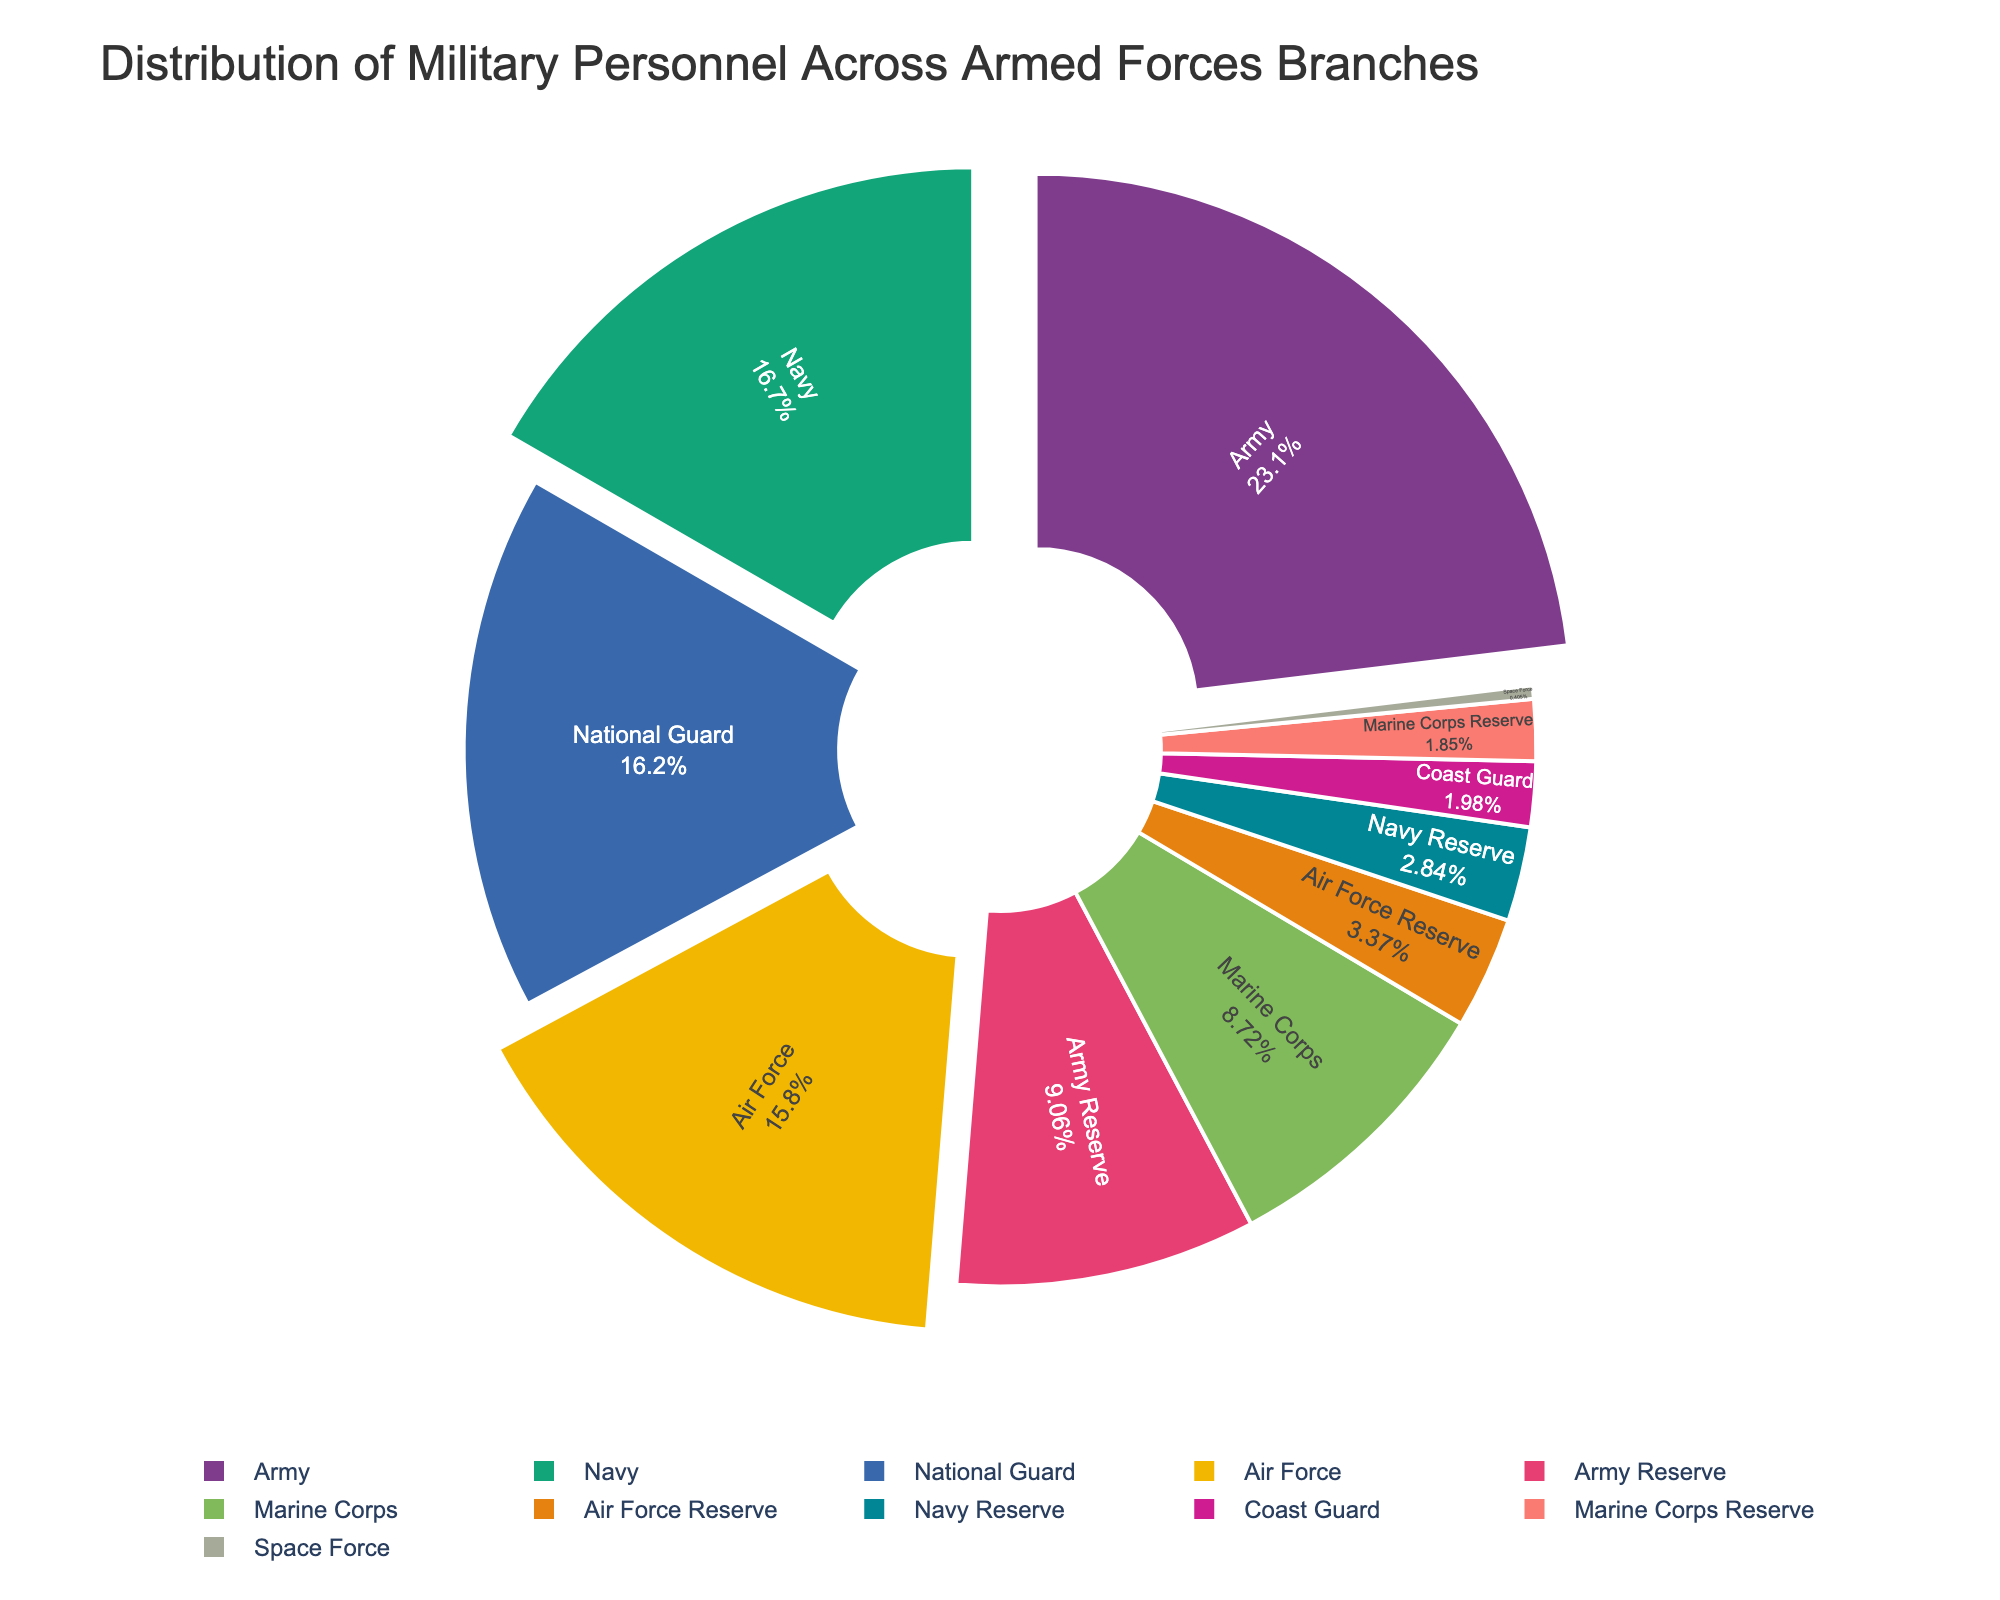Which branch has the highest percentage of military personnel? The percentage for each branch is shown on the pie chart. The Army segment is the largest, indicating the highest percentage of military personnel.
Answer: Army How does the number of personnel in the Marine Corps compare to the Air Force? The pie chart shows segments labeled with percentages and names. The Marine Corps' segment is smaller than the Air Force's, indicating fewer personnel.
Answer: Air Force has more What is the combined percentage of personnel in the Navy and the Marine Corps? Identify and sum the percentages for both segments: Navy's percentage plus the Marine Corps' percentage.
Answer: Navy + Marine Corps' percentage Which branch has the smallest share of military personnel? Look at the segment with the smallest label; the Space Force takes up the smallest portion of the pie chart.
Answer: Space Force Is the personnel in the National Guard greater than the personnel in the Air Force? Compare the sizes of their respective segments. The National Guard segment is larger, indicating more personnel.
Answer: Yes How many branches have more than 100,000 personnel? Count the segments with percentages that indicate a high number of personnel. These would be Army, Navy, Air Force, National Guard, Army Reserve.
Answer: Five What is the total percentage of reserve personnel across all branches? Add the percentages for Army Reserve, Navy Reserve, Air Force Reserve, and Marine Corps Reserve segments.
Answer: Sum of reserve percentages Which two branches have a combined percentage closest to that of the Army? Compare the Army segment's size to various combinations of other segments, finding that the Navy and National Guard segments together closely match.
Answer: Navy + National Guard How does the Coast Guard's percentage compare to that of the Space Force? The Coast Guard segment is larger than the Space Force's, indicating a higher percentage of personnel.
Answer: Coast Guard has more What is the visual representation method used to show differentiation among segments? The pie chart utilizes different colors for each segment and some segments are pulled out slightly.
Answer: Colors and pull-out feature 